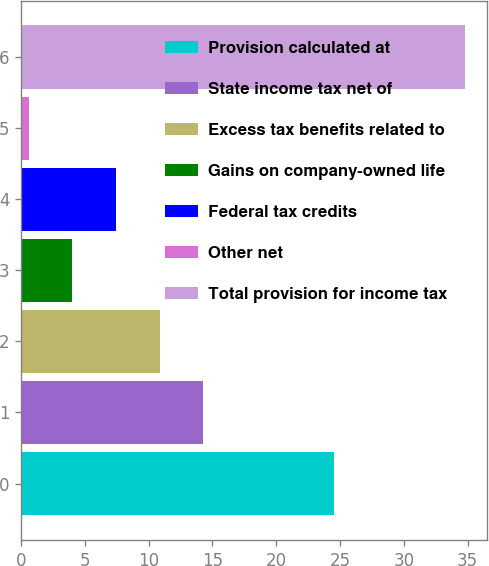<chart> <loc_0><loc_0><loc_500><loc_500><bar_chart><fcel>Provision calculated at<fcel>State income tax net of<fcel>Excess tax benefits related to<fcel>Gains on company-owned life<fcel>Federal tax credits<fcel>Other net<fcel>Total provision for income tax<nl><fcel>24.5<fcel>14.28<fcel>10.86<fcel>4.02<fcel>7.44<fcel>0.6<fcel>34.8<nl></chart> 